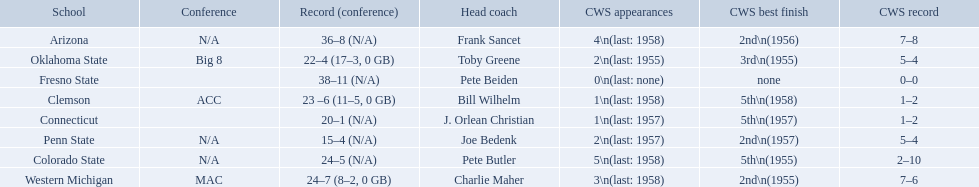Which teams played in the 1959 ncaa university division baseball tournament? Arizona, Clemson, Colorado State, Connecticut, Fresno State, Oklahoma State, Penn State, Western Michigan. Which was the only one to win less than 20 games? Penn State. 